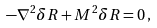<formula> <loc_0><loc_0><loc_500><loc_500>- \nabla ^ { 2 } \delta R + M ^ { 2 } \delta R = 0 \, ,</formula> 